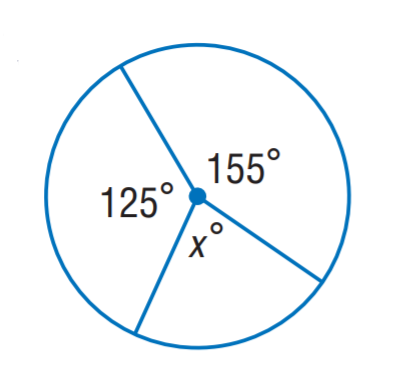Question: Find x.
Choices:
A. 60
B. 80
C. 125
D. 155
Answer with the letter. Answer: B 